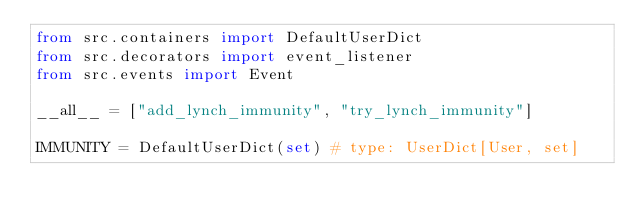<code> <loc_0><loc_0><loc_500><loc_500><_Python_>from src.containers import DefaultUserDict
from src.decorators import event_listener
from src.events import Event

__all__ = ["add_lynch_immunity", "try_lynch_immunity"]

IMMUNITY = DefaultUserDict(set) # type: UserDict[User, set]
</code> 